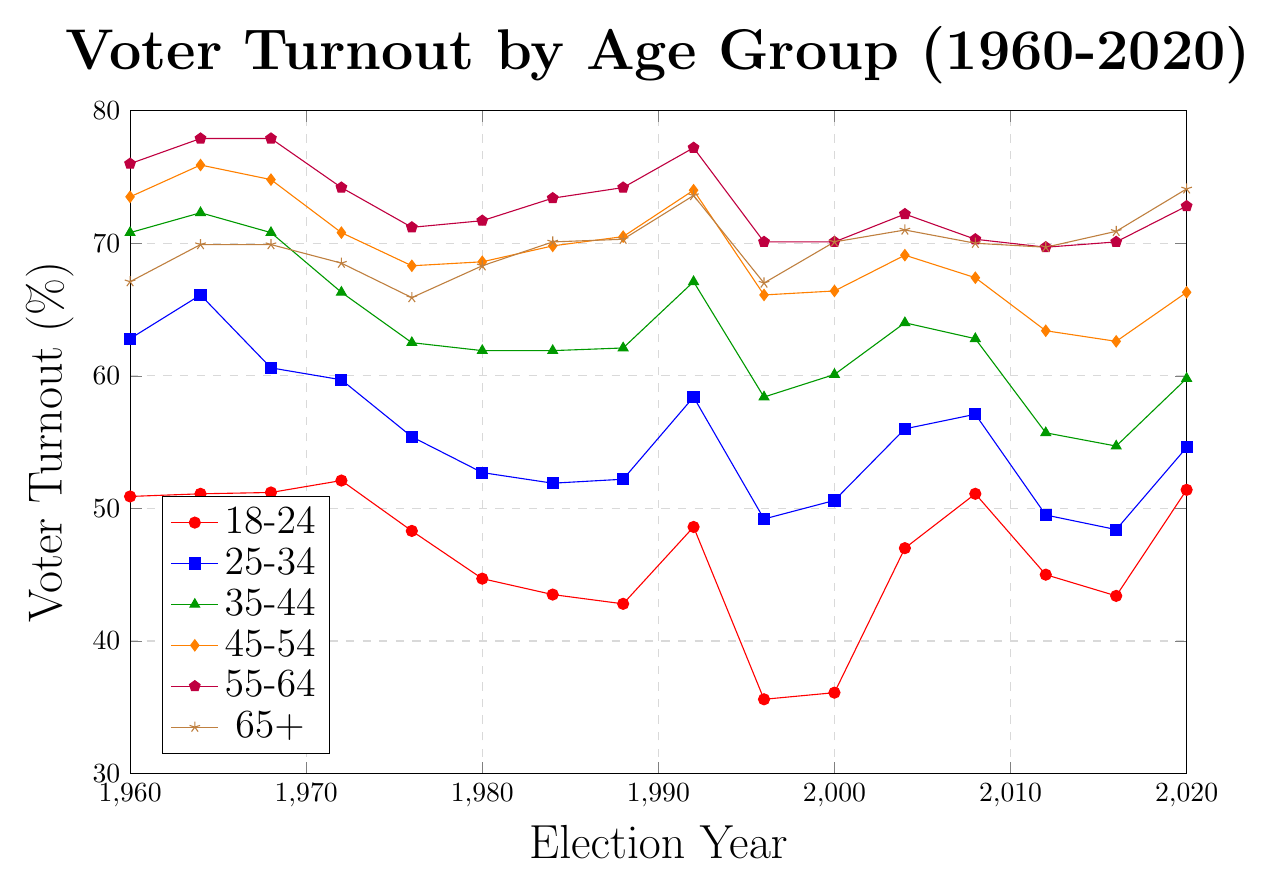What is the trend in voter turnout among the 18-24 age group from 1960 to 2020? The voter turnout for the 18-24 age group showed a general decrease from 50.9% in 1960 to 35.6% in 1996, then increased again, especially from 2000 onwards with peaks in 2004 and 2020 at 47% and 51.4% respectively.
Answer: Decreasing until 1996, then increasing Which age group had the highest voter turnout rate in the year 2000? To find the highest voter turnout in 2000, compare the data points: 18-24 (36.1%), 25-34 (50.6%), 35-44 (60.1%), 45-54 (66.4%), 55-64 (70.1%), and 65+ (70.1%). The 55-64 and 65+ groups both had the highest at 70.1%.
Answer: 55-64 and 65+ How did voter turnout change in the 45-54 age group between 1980 and 2000? The voter turnout in the 45-54 age group was 68.6% in 1980 and 66.4% in 2000. The difference is 66.4% - 68.6% = -2.2%, reflecting a slight decrease.
Answer: Decreased by 2.2% Comparing the year 2004, which age groups had a voter turnout above 60%? Checking the voter turnout values for 2004: 18-24 (47.0%), 25-34 (56.0%), 35-44 (64.0%), 45-54 (69.1%), 55-64 (72.2%), and 65+ (71.0%). The groups 35-44, 45-54, 55-64, and 65+ had turnout above 60%.
Answer: 35-44, 45-54, 55-64, 65+ What is the difference between the highest and lowest voter turnout among all age groups in 1984? In 1984, the turnout rates were: 18-24 (43.5%), 25-34 (51.9%), 35-44 (61.9%), 45-54 (69.8%), 55-64 (73.4%), 65+ (70.1%). The highest is 73.4% (55-64) and the lowest is 43.5% (18-24), with a difference of 73.4% - 43.5% = 29.9%.
Answer: 29.9% What is the average voter turnout for the 65+ age group from 1960 to 2020? First, sum the turnout rates for the 65+ age group: 67.1 + 69.9 + 69.9 + 68.5 + 65.9 + 68.3 + 70.1 + 70.3 + 73.6 + 67.0 + 70.1 + 71.0 + 70.0 + 69.7 + 70.9 + 74.1 = 1176.4. Then divide by the number of data points, which is 16: 1176.4 / 16 ≈ 73.5.
Answer: 67.0% Which age group had the lowest voter turnout in 1996, and what was the value? Checking the values for 1996: 18-24 (35.6%), 25-34 (49.2%), 35-44 (58.4%), 45-54 (66.1%), 55-64 (70.1%), and 65+ (67.0%). The 18-24 age group had the lowest turnout at 35.6%.
Answer: 18-24 with 35.6% In 2020, which age group saw a voter turnout increase compared to 2016? Comparing 2016 and 2020 values: 18-24 (43.4% to 51.4%), 25-34 (48.4% to 54.6%), 35-44 (54.7% to 59.8%), 45-54 (62.6% to 66.3%), 55-64 (70.1% to 72.8%), 65+ (70.9% to 74.1%). All age groups saw an increase.
Answer: All age groups How did the 18-24 age group voter turnout in 2020 compare to its voter turnout in 2008? The voter turnout for the 18-24 age group in 2020 was 51.4%, while in 2008 it was 51.1%. The difference is 51.4% - 51.1% = 0.3%, indicating a slight increase.
Answer: Increased by 0.3% 